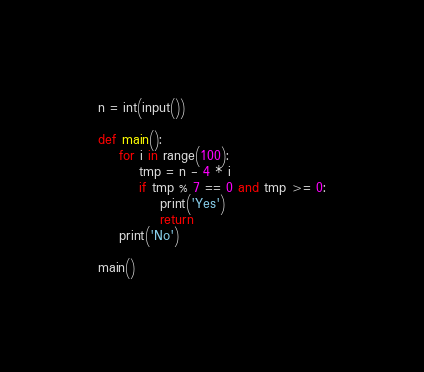<code> <loc_0><loc_0><loc_500><loc_500><_Python_>n = int(input())

def main():
    for i in range(100):
        tmp = n - 4 * i
        if tmp % 7 == 0 and tmp >= 0:
            print('Yes')
            return
    print('No')

main()</code> 